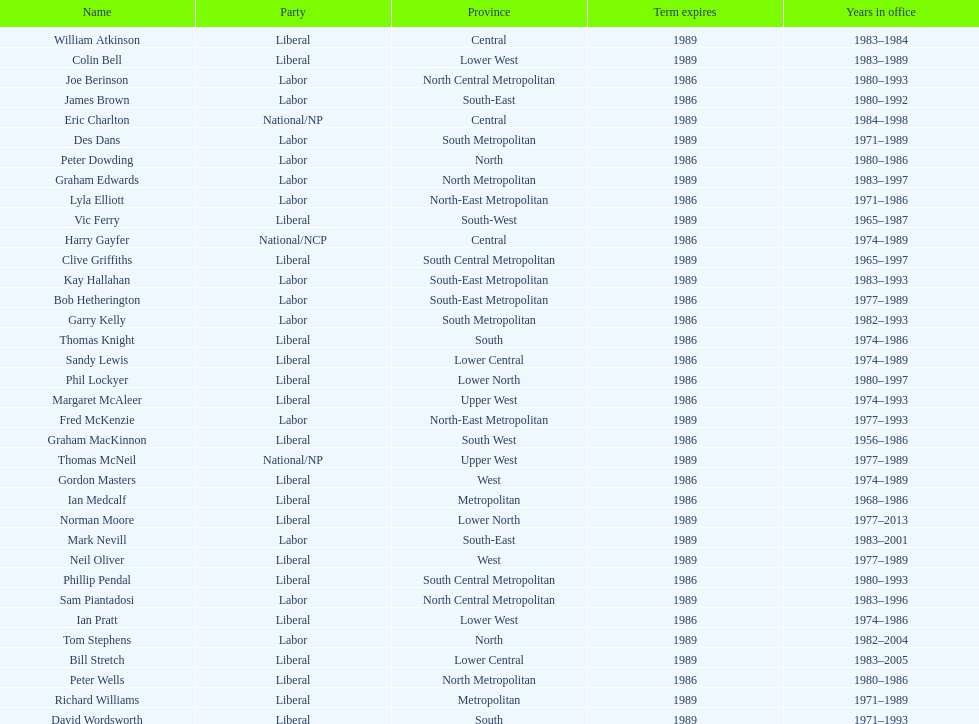What is the total number of members whose term expires in 1989? 9. Write the full table. {'header': ['Name', 'Party', 'Province', 'Term expires', 'Years in office'], 'rows': [['William Atkinson', 'Liberal', 'Central', '1989', '1983–1984'], ['Colin Bell', 'Liberal', 'Lower West', '1989', '1983–1989'], ['Joe Berinson', 'Labor', 'North Central Metropolitan', '1986', '1980–1993'], ['James Brown', 'Labor', 'South-East', '1986', '1980–1992'], ['Eric Charlton', 'National/NP', 'Central', '1989', '1984–1998'], ['Des Dans', 'Labor', 'South Metropolitan', '1989', '1971–1989'], ['Peter Dowding', 'Labor', 'North', '1986', '1980–1986'], ['Graham Edwards', 'Labor', 'North Metropolitan', '1989', '1983–1997'], ['Lyla Elliott', 'Labor', 'North-East Metropolitan', '1986', '1971–1986'], ['Vic Ferry', 'Liberal', 'South-West', '1989', '1965–1987'], ['Harry Gayfer', 'National/NCP', 'Central', '1986', '1974–1989'], ['Clive Griffiths', 'Liberal', 'South Central Metropolitan', '1989', '1965–1997'], ['Kay Hallahan', 'Labor', 'South-East Metropolitan', '1989', '1983–1993'], ['Bob Hetherington', 'Labor', 'South-East Metropolitan', '1986', '1977–1989'], ['Garry Kelly', 'Labor', 'South Metropolitan', '1986', '1982–1993'], ['Thomas Knight', 'Liberal', 'South', '1986', '1974–1986'], ['Sandy Lewis', 'Liberal', 'Lower Central', '1986', '1974–1989'], ['Phil Lockyer', 'Liberal', 'Lower North', '1986', '1980–1997'], ['Margaret McAleer', 'Liberal', 'Upper West', '1986', '1974–1993'], ['Fred McKenzie', 'Labor', 'North-East Metropolitan', '1989', '1977–1993'], ['Graham MacKinnon', 'Liberal', 'South West', '1986', '1956–1986'], ['Thomas McNeil', 'National/NP', 'Upper West', '1989', '1977–1989'], ['Gordon Masters', 'Liberal', 'West', '1986', '1974–1989'], ['Ian Medcalf', 'Liberal', 'Metropolitan', '1986', '1968–1986'], ['Norman Moore', 'Liberal', 'Lower North', '1989', '1977–2013'], ['Mark Nevill', 'Labor', 'South-East', '1989', '1983–2001'], ['Neil Oliver', 'Liberal', 'West', '1989', '1977–1989'], ['Phillip Pendal', 'Liberal', 'South Central Metropolitan', '1986', '1980–1993'], ['Sam Piantadosi', 'Labor', 'North Central Metropolitan', '1989', '1983–1996'], ['Ian Pratt', 'Liberal', 'Lower West', '1986', '1974–1986'], ['Tom Stephens', 'Labor', 'North', '1989', '1982–2004'], ['Bill Stretch', 'Liberal', 'Lower Central', '1989', '1983–2005'], ['Peter Wells', 'Liberal', 'North Metropolitan', '1986', '1980–1986'], ['Richard Williams', 'Liberal', 'Metropolitan', '1989', '1971–1989'], ['David Wordsworth', 'Liberal', 'South', '1989', '1971–1993']]} 